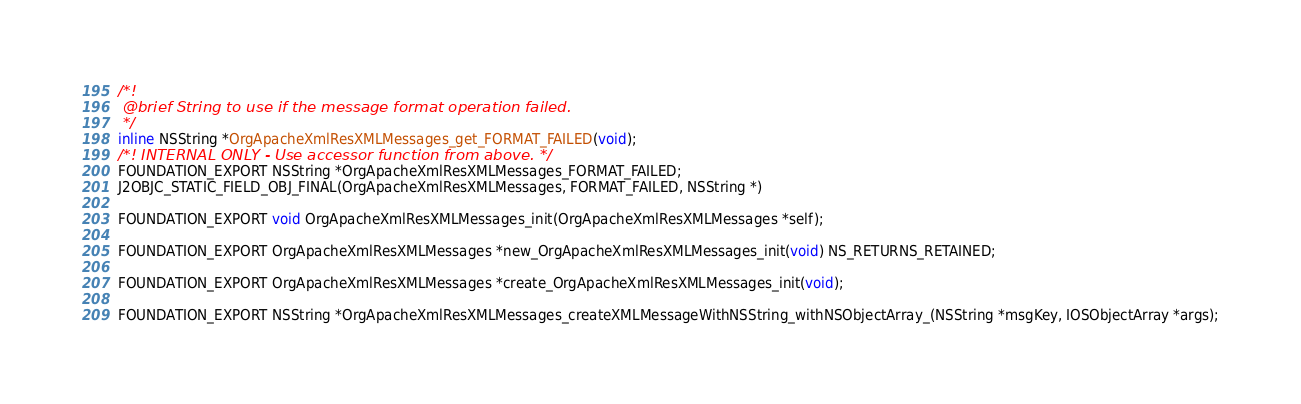Convert code to text. <code><loc_0><loc_0><loc_500><loc_500><_C_>/*!
 @brief String to use if the message format operation failed.
 */
inline NSString *OrgApacheXmlResXMLMessages_get_FORMAT_FAILED(void);
/*! INTERNAL ONLY - Use accessor function from above. */
FOUNDATION_EXPORT NSString *OrgApacheXmlResXMLMessages_FORMAT_FAILED;
J2OBJC_STATIC_FIELD_OBJ_FINAL(OrgApacheXmlResXMLMessages, FORMAT_FAILED, NSString *)

FOUNDATION_EXPORT void OrgApacheXmlResXMLMessages_init(OrgApacheXmlResXMLMessages *self);

FOUNDATION_EXPORT OrgApacheXmlResXMLMessages *new_OrgApacheXmlResXMLMessages_init(void) NS_RETURNS_RETAINED;

FOUNDATION_EXPORT OrgApacheXmlResXMLMessages *create_OrgApacheXmlResXMLMessages_init(void);

FOUNDATION_EXPORT NSString *OrgApacheXmlResXMLMessages_createXMLMessageWithNSString_withNSObjectArray_(NSString *msgKey, IOSObjectArray *args);
</code> 